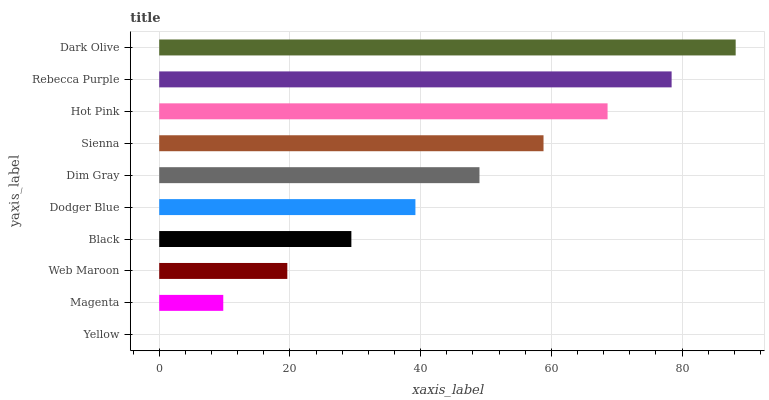Is Yellow the minimum?
Answer yes or no. Yes. Is Dark Olive the maximum?
Answer yes or no. Yes. Is Magenta the minimum?
Answer yes or no. No. Is Magenta the maximum?
Answer yes or no. No. Is Magenta greater than Yellow?
Answer yes or no. Yes. Is Yellow less than Magenta?
Answer yes or no. Yes. Is Yellow greater than Magenta?
Answer yes or no. No. Is Magenta less than Yellow?
Answer yes or no. No. Is Dim Gray the high median?
Answer yes or no. Yes. Is Dodger Blue the low median?
Answer yes or no. Yes. Is Black the high median?
Answer yes or no. No. Is Hot Pink the low median?
Answer yes or no. No. 